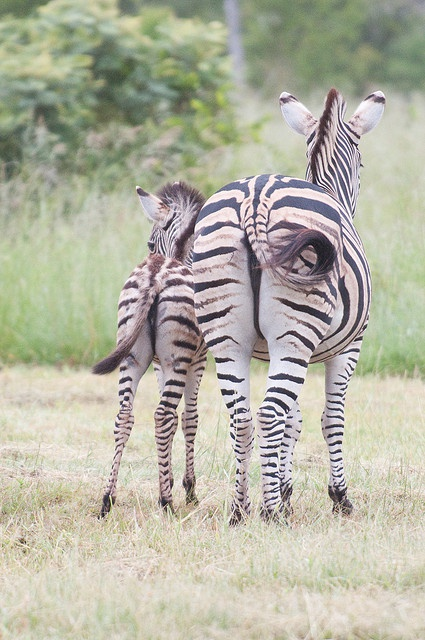Describe the objects in this image and their specific colors. I can see zebra in olive, lightgray, darkgray, gray, and black tones and zebra in olive, darkgray, lightgray, and gray tones in this image. 